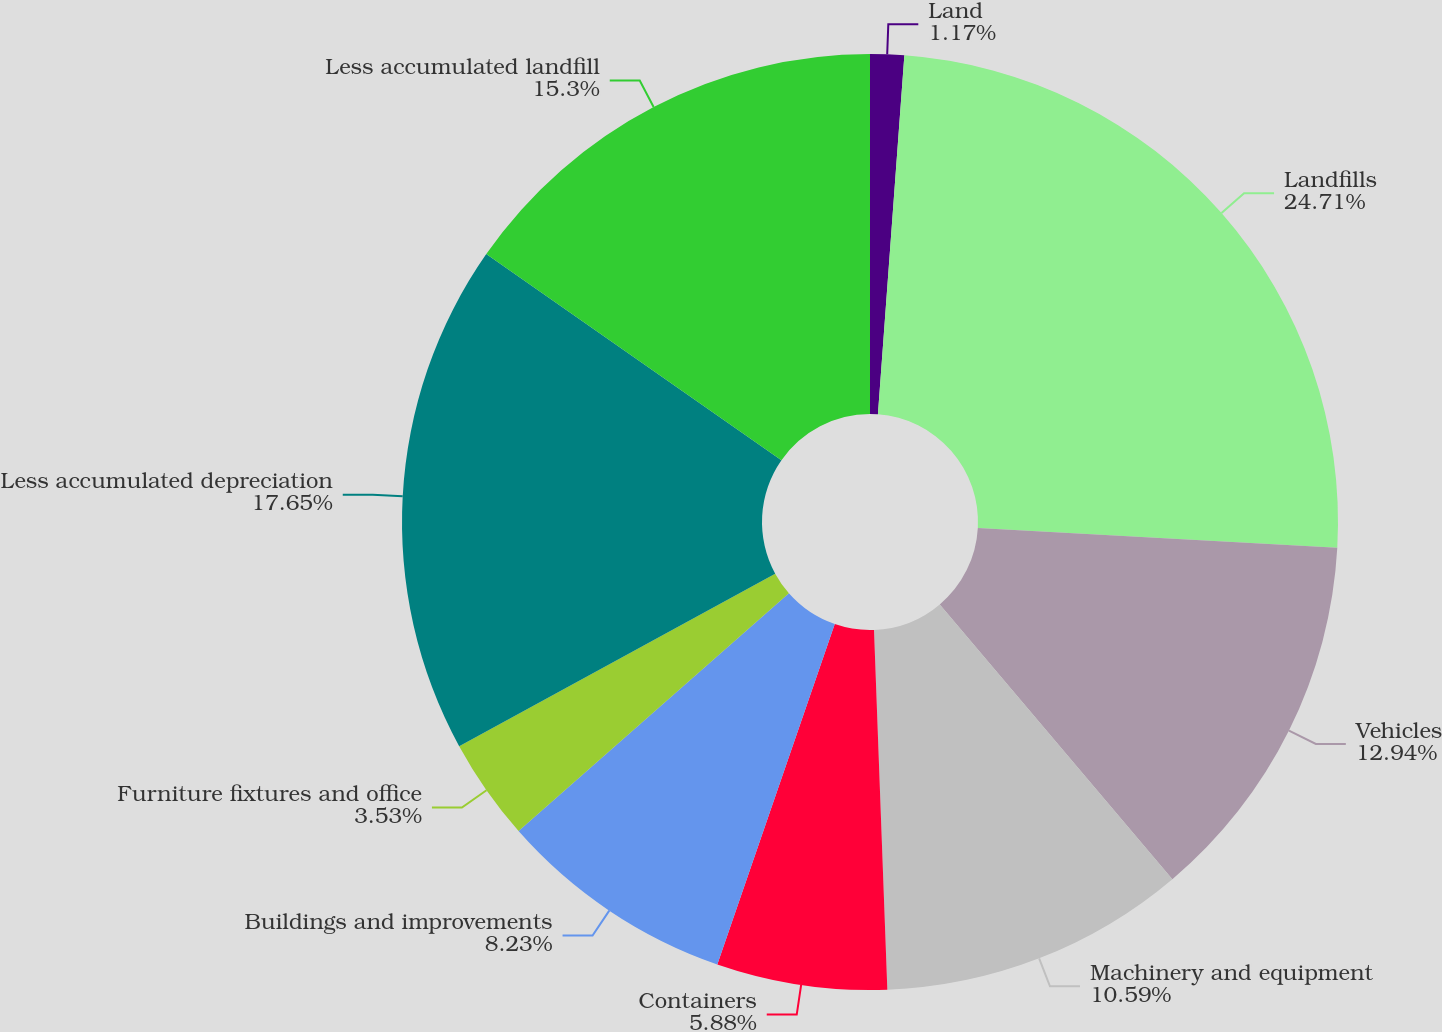<chart> <loc_0><loc_0><loc_500><loc_500><pie_chart><fcel>Land<fcel>Landfills<fcel>Vehicles<fcel>Machinery and equipment<fcel>Containers<fcel>Buildings and improvements<fcel>Furniture fixtures and office<fcel>Less accumulated depreciation<fcel>Less accumulated landfill<nl><fcel>1.17%<fcel>24.71%<fcel>12.94%<fcel>10.59%<fcel>5.88%<fcel>8.23%<fcel>3.53%<fcel>17.65%<fcel>15.3%<nl></chart> 